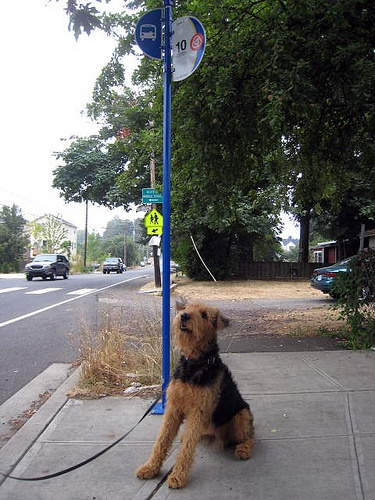Describe the objects in this image and their specific colors. I can see dog in white, black, maroon, and gray tones, car in white, lavender, black, and gray tones, car in white, black, gray, blue, and navy tones, car in white, lavender, gray, black, and darkgray tones, and car in white, lavender, gray, and navy tones in this image. 